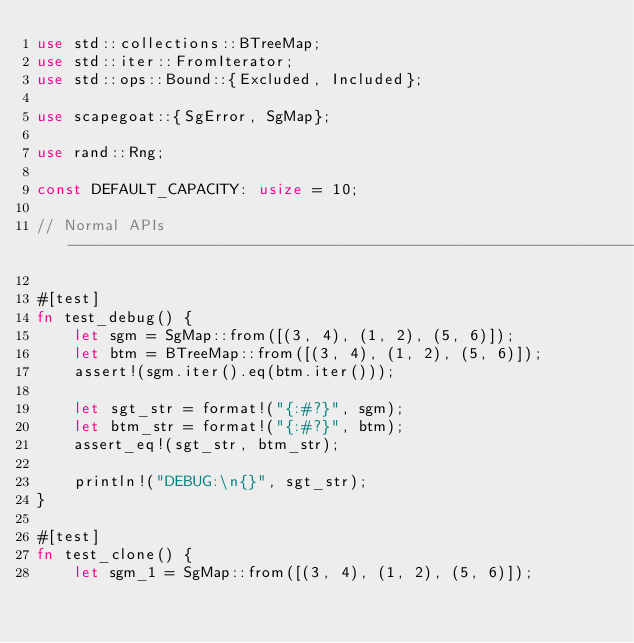<code> <loc_0><loc_0><loc_500><loc_500><_Rust_>use std::collections::BTreeMap;
use std::iter::FromIterator;
use std::ops::Bound::{Excluded, Included};

use scapegoat::{SgError, SgMap};

use rand::Rng;

const DEFAULT_CAPACITY: usize = 10;

// Normal APIs ---------------------------------------------------------------------------------------------------------

#[test]
fn test_debug() {
    let sgm = SgMap::from([(3, 4), (1, 2), (5, 6)]);
    let btm = BTreeMap::from([(3, 4), (1, 2), (5, 6)]);
    assert!(sgm.iter().eq(btm.iter()));

    let sgt_str = format!("{:#?}", sgm);
    let btm_str = format!("{:#?}", btm);
    assert_eq!(sgt_str, btm_str);

    println!("DEBUG:\n{}", sgt_str);
}

#[test]
fn test_clone() {
    let sgm_1 = SgMap::from([(3, 4), (1, 2), (5, 6)]);</code> 